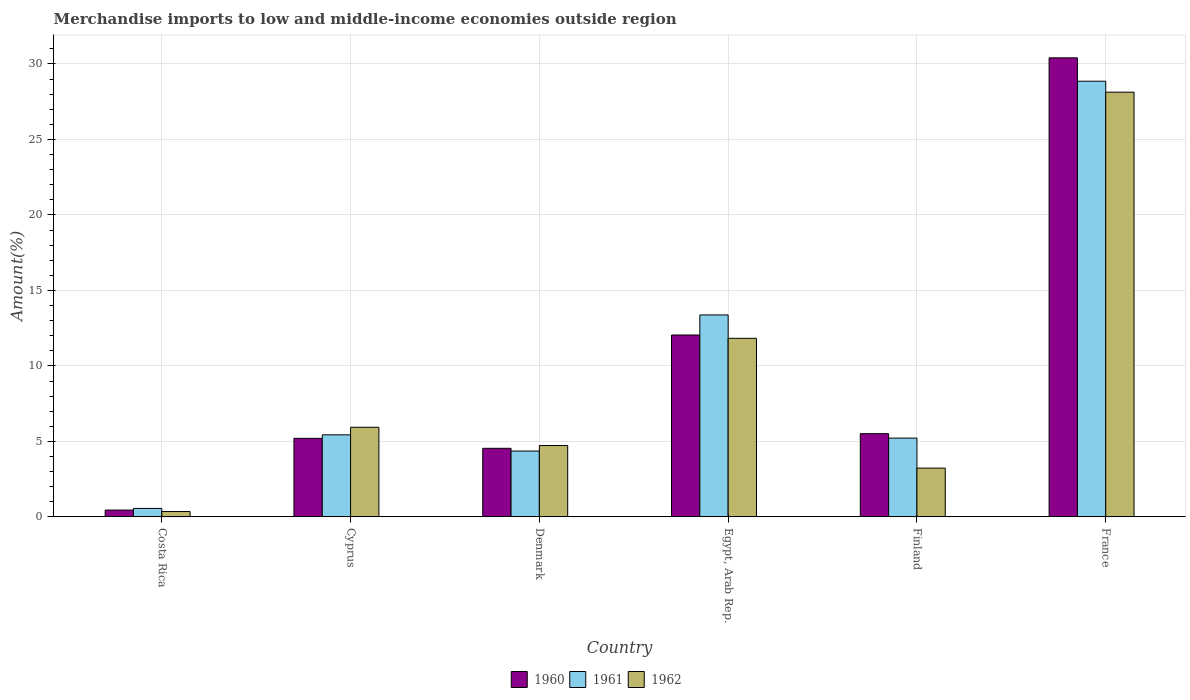Are the number of bars on each tick of the X-axis equal?
Offer a terse response. Yes. What is the percentage of amount earned from merchandise imports in 1960 in Finland?
Your answer should be very brief. 5.51. Across all countries, what is the maximum percentage of amount earned from merchandise imports in 1961?
Your answer should be very brief. 28.86. Across all countries, what is the minimum percentage of amount earned from merchandise imports in 1960?
Keep it short and to the point. 0.45. In which country was the percentage of amount earned from merchandise imports in 1961 maximum?
Keep it short and to the point. France. What is the total percentage of amount earned from merchandise imports in 1962 in the graph?
Your answer should be very brief. 54.22. What is the difference between the percentage of amount earned from merchandise imports in 1961 in Denmark and that in Finland?
Make the answer very short. -0.86. What is the difference between the percentage of amount earned from merchandise imports in 1962 in Cyprus and the percentage of amount earned from merchandise imports in 1960 in Finland?
Keep it short and to the point. 0.43. What is the average percentage of amount earned from merchandise imports in 1962 per country?
Ensure brevity in your answer.  9.04. What is the difference between the percentage of amount earned from merchandise imports of/in 1961 and percentage of amount earned from merchandise imports of/in 1960 in Finland?
Ensure brevity in your answer.  -0.29. In how many countries, is the percentage of amount earned from merchandise imports in 1961 greater than 22 %?
Your answer should be compact. 1. What is the ratio of the percentage of amount earned from merchandise imports in 1961 in Denmark to that in France?
Offer a very short reply. 0.15. Is the percentage of amount earned from merchandise imports in 1961 in Denmark less than that in France?
Provide a short and direct response. Yes. Is the difference between the percentage of amount earned from merchandise imports in 1961 in Costa Rica and Cyprus greater than the difference between the percentage of amount earned from merchandise imports in 1960 in Costa Rica and Cyprus?
Offer a terse response. No. What is the difference between the highest and the second highest percentage of amount earned from merchandise imports in 1962?
Keep it short and to the point. -16.3. What is the difference between the highest and the lowest percentage of amount earned from merchandise imports in 1961?
Ensure brevity in your answer.  28.29. In how many countries, is the percentage of amount earned from merchandise imports in 1960 greater than the average percentage of amount earned from merchandise imports in 1960 taken over all countries?
Ensure brevity in your answer.  2. Is it the case that in every country, the sum of the percentage of amount earned from merchandise imports in 1962 and percentage of amount earned from merchandise imports in 1961 is greater than the percentage of amount earned from merchandise imports in 1960?
Offer a terse response. Yes. How many bars are there?
Give a very brief answer. 18. How many countries are there in the graph?
Your response must be concise. 6. Does the graph contain grids?
Keep it short and to the point. Yes. How many legend labels are there?
Provide a succinct answer. 3. What is the title of the graph?
Your answer should be compact. Merchandise imports to low and middle-income economies outside region. Does "1960" appear as one of the legend labels in the graph?
Offer a very short reply. Yes. What is the label or title of the Y-axis?
Make the answer very short. Amount(%). What is the Amount(%) of 1960 in Costa Rica?
Offer a very short reply. 0.45. What is the Amount(%) in 1961 in Costa Rica?
Your answer should be compact. 0.56. What is the Amount(%) in 1962 in Costa Rica?
Give a very brief answer. 0.36. What is the Amount(%) in 1960 in Cyprus?
Provide a short and direct response. 5.21. What is the Amount(%) of 1961 in Cyprus?
Provide a short and direct response. 5.44. What is the Amount(%) of 1962 in Cyprus?
Provide a short and direct response. 5.94. What is the Amount(%) of 1960 in Denmark?
Keep it short and to the point. 4.54. What is the Amount(%) of 1961 in Denmark?
Make the answer very short. 4.36. What is the Amount(%) of 1962 in Denmark?
Provide a short and direct response. 4.73. What is the Amount(%) of 1960 in Egypt, Arab Rep.?
Make the answer very short. 12.05. What is the Amount(%) of 1961 in Egypt, Arab Rep.?
Ensure brevity in your answer.  13.38. What is the Amount(%) of 1962 in Egypt, Arab Rep.?
Provide a succinct answer. 11.83. What is the Amount(%) in 1960 in Finland?
Keep it short and to the point. 5.51. What is the Amount(%) of 1961 in Finland?
Ensure brevity in your answer.  5.22. What is the Amount(%) of 1962 in Finland?
Your answer should be compact. 3.23. What is the Amount(%) in 1960 in France?
Give a very brief answer. 30.4. What is the Amount(%) of 1961 in France?
Provide a short and direct response. 28.86. What is the Amount(%) of 1962 in France?
Provide a short and direct response. 28.13. Across all countries, what is the maximum Amount(%) of 1960?
Make the answer very short. 30.4. Across all countries, what is the maximum Amount(%) of 1961?
Offer a very short reply. 28.86. Across all countries, what is the maximum Amount(%) of 1962?
Provide a succinct answer. 28.13. Across all countries, what is the minimum Amount(%) in 1960?
Keep it short and to the point. 0.45. Across all countries, what is the minimum Amount(%) of 1961?
Provide a short and direct response. 0.56. Across all countries, what is the minimum Amount(%) of 1962?
Give a very brief answer. 0.36. What is the total Amount(%) of 1960 in the graph?
Keep it short and to the point. 58.17. What is the total Amount(%) of 1961 in the graph?
Keep it short and to the point. 57.82. What is the total Amount(%) of 1962 in the graph?
Offer a very short reply. 54.22. What is the difference between the Amount(%) in 1960 in Costa Rica and that in Cyprus?
Offer a terse response. -4.75. What is the difference between the Amount(%) in 1961 in Costa Rica and that in Cyprus?
Provide a succinct answer. -4.87. What is the difference between the Amount(%) in 1962 in Costa Rica and that in Cyprus?
Offer a terse response. -5.58. What is the difference between the Amount(%) in 1960 in Costa Rica and that in Denmark?
Provide a short and direct response. -4.09. What is the difference between the Amount(%) in 1961 in Costa Rica and that in Denmark?
Give a very brief answer. -3.8. What is the difference between the Amount(%) of 1962 in Costa Rica and that in Denmark?
Make the answer very short. -4.37. What is the difference between the Amount(%) of 1960 in Costa Rica and that in Egypt, Arab Rep.?
Give a very brief answer. -11.59. What is the difference between the Amount(%) in 1961 in Costa Rica and that in Egypt, Arab Rep.?
Offer a terse response. -12.81. What is the difference between the Amount(%) of 1962 in Costa Rica and that in Egypt, Arab Rep.?
Provide a short and direct response. -11.47. What is the difference between the Amount(%) of 1960 in Costa Rica and that in Finland?
Provide a succinct answer. -5.06. What is the difference between the Amount(%) in 1961 in Costa Rica and that in Finland?
Give a very brief answer. -4.66. What is the difference between the Amount(%) in 1962 in Costa Rica and that in Finland?
Provide a succinct answer. -2.88. What is the difference between the Amount(%) of 1960 in Costa Rica and that in France?
Offer a terse response. -29.95. What is the difference between the Amount(%) in 1961 in Costa Rica and that in France?
Your response must be concise. -28.29. What is the difference between the Amount(%) of 1962 in Costa Rica and that in France?
Your response must be concise. -27.77. What is the difference between the Amount(%) in 1960 in Cyprus and that in Denmark?
Provide a short and direct response. 0.66. What is the difference between the Amount(%) in 1961 in Cyprus and that in Denmark?
Give a very brief answer. 1.07. What is the difference between the Amount(%) of 1962 in Cyprus and that in Denmark?
Keep it short and to the point. 1.21. What is the difference between the Amount(%) in 1960 in Cyprus and that in Egypt, Arab Rep.?
Ensure brevity in your answer.  -6.84. What is the difference between the Amount(%) in 1961 in Cyprus and that in Egypt, Arab Rep.?
Your answer should be compact. -7.94. What is the difference between the Amount(%) of 1962 in Cyprus and that in Egypt, Arab Rep.?
Ensure brevity in your answer.  -5.89. What is the difference between the Amount(%) of 1960 in Cyprus and that in Finland?
Provide a succinct answer. -0.31. What is the difference between the Amount(%) of 1961 in Cyprus and that in Finland?
Your response must be concise. 0.22. What is the difference between the Amount(%) of 1962 in Cyprus and that in Finland?
Ensure brevity in your answer.  2.71. What is the difference between the Amount(%) of 1960 in Cyprus and that in France?
Give a very brief answer. -25.2. What is the difference between the Amount(%) of 1961 in Cyprus and that in France?
Offer a very short reply. -23.42. What is the difference between the Amount(%) in 1962 in Cyprus and that in France?
Your response must be concise. -22.19. What is the difference between the Amount(%) in 1960 in Denmark and that in Egypt, Arab Rep.?
Provide a short and direct response. -7.5. What is the difference between the Amount(%) in 1961 in Denmark and that in Egypt, Arab Rep.?
Offer a terse response. -9.01. What is the difference between the Amount(%) of 1962 in Denmark and that in Egypt, Arab Rep.?
Provide a succinct answer. -7.1. What is the difference between the Amount(%) of 1960 in Denmark and that in Finland?
Make the answer very short. -0.97. What is the difference between the Amount(%) of 1961 in Denmark and that in Finland?
Provide a succinct answer. -0.86. What is the difference between the Amount(%) in 1962 in Denmark and that in Finland?
Offer a very short reply. 1.49. What is the difference between the Amount(%) of 1960 in Denmark and that in France?
Offer a terse response. -25.86. What is the difference between the Amount(%) in 1961 in Denmark and that in France?
Make the answer very short. -24.49. What is the difference between the Amount(%) in 1962 in Denmark and that in France?
Give a very brief answer. -23.4. What is the difference between the Amount(%) in 1960 in Egypt, Arab Rep. and that in Finland?
Give a very brief answer. 6.54. What is the difference between the Amount(%) in 1961 in Egypt, Arab Rep. and that in Finland?
Keep it short and to the point. 8.16. What is the difference between the Amount(%) of 1962 in Egypt, Arab Rep. and that in Finland?
Your answer should be compact. 8.6. What is the difference between the Amount(%) of 1960 in Egypt, Arab Rep. and that in France?
Provide a succinct answer. -18.36. What is the difference between the Amount(%) in 1961 in Egypt, Arab Rep. and that in France?
Ensure brevity in your answer.  -15.48. What is the difference between the Amount(%) of 1962 in Egypt, Arab Rep. and that in France?
Offer a terse response. -16.3. What is the difference between the Amount(%) in 1960 in Finland and that in France?
Give a very brief answer. -24.89. What is the difference between the Amount(%) in 1961 in Finland and that in France?
Provide a succinct answer. -23.64. What is the difference between the Amount(%) in 1962 in Finland and that in France?
Offer a very short reply. -24.9. What is the difference between the Amount(%) of 1960 in Costa Rica and the Amount(%) of 1961 in Cyprus?
Your answer should be compact. -4.98. What is the difference between the Amount(%) in 1960 in Costa Rica and the Amount(%) in 1962 in Cyprus?
Keep it short and to the point. -5.48. What is the difference between the Amount(%) in 1961 in Costa Rica and the Amount(%) in 1962 in Cyprus?
Give a very brief answer. -5.38. What is the difference between the Amount(%) in 1960 in Costa Rica and the Amount(%) in 1961 in Denmark?
Your answer should be compact. -3.91. What is the difference between the Amount(%) in 1960 in Costa Rica and the Amount(%) in 1962 in Denmark?
Keep it short and to the point. -4.27. What is the difference between the Amount(%) of 1961 in Costa Rica and the Amount(%) of 1962 in Denmark?
Keep it short and to the point. -4.16. What is the difference between the Amount(%) in 1960 in Costa Rica and the Amount(%) in 1961 in Egypt, Arab Rep.?
Offer a very short reply. -12.92. What is the difference between the Amount(%) of 1960 in Costa Rica and the Amount(%) of 1962 in Egypt, Arab Rep.?
Provide a short and direct response. -11.37. What is the difference between the Amount(%) of 1961 in Costa Rica and the Amount(%) of 1962 in Egypt, Arab Rep.?
Offer a terse response. -11.27. What is the difference between the Amount(%) of 1960 in Costa Rica and the Amount(%) of 1961 in Finland?
Your response must be concise. -4.76. What is the difference between the Amount(%) in 1960 in Costa Rica and the Amount(%) in 1962 in Finland?
Offer a very short reply. -2.78. What is the difference between the Amount(%) in 1961 in Costa Rica and the Amount(%) in 1962 in Finland?
Give a very brief answer. -2.67. What is the difference between the Amount(%) in 1960 in Costa Rica and the Amount(%) in 1961 in France?
Ensure brevity in your answer.  -28.4. What is the difference between the Amount(%) in 1960 in Costa Rica and the Amount(%) in 1962 in France?
Offer a very short reply. -27.67. What is the difference between the Amount(%) of 1961 in Costa Rica and the Amount(%) of 1962 in France?
Provide a short and direct response. -27.57. What is the difference between the Amount(%) in 1960 in Cyprus and the Amount(%) in 1961 in Denmark?
Ensure brevity in your answer.  0.84. What is the difference between the Amount(%) in 1960 in Cyprus and the Amount(%) in 1962 in Denmark?
Offer a very short reply. 0.48. What is the difference between the Amount(%) of 1961 in Cyprus and the Amount(%) of 1962 in Denmark?
Offer a very short reply. 0.71. What is the difference between the Amount(%) of 1960 in Cyprus and the Amount(%) of 1961 in Egypt, Arab Rep.?
Offer a very short reply. -8.17. What is the difference between the Amount(%) of 1960 in Cyprus and the Amount(%) of 1962 in Egypt, Arab Rep.?
Your response must be concise. -6.62. What is the difference between the Amount(%) of 1961 in Cyprus and the Amount(%) of 1962 in Egypt, Arab Rep.?
Ensure brevity in your answer.  -6.39. What is the difference between the Amount(%) of 1960 in Cyprus and the Amount(%) of 1961 in Finland?
Provide a succinct answer. -0.01. What is the difference between the Amount(%) of 1960 in Cyprus and the Amount(%) of 1962 in Finland?
Offer a terse response. 1.97. What is the difference between the Amount(%) of 1961 in Cyprus and the Amount(%) of 1962 in Finland?
Provide a short and direct response. 2.2. What is the difference between the Amount(%) of 1960 in Cyprus and the Amount(%) of 1961 in France?
Keep it short and to the point. -23.65. What is the difference between the Amount(%) in 1960 in Cyprus and the Amount(%) in 1962 in France?
Ensure brevity in your answer.  -22.92. What is the difference between the Amount(%) in 1961 in Cyprus and the Amount(%) in 1962 in France?
Keep it short and to the point. -22.69. What is the difference between the Amount(%) of 1960 in Denmark and the Amount(%) of 1961 in Egypt, Arab Rep.?
Offer a very short reply. -8.83. What is the difference between the Amount(%) of 1960 in Denmark and the Amount(%) of 1962 in Egypt, Arab Rep.?
Your answer should be very brief. -7.28. What is the difference between the Amount(%) of 1961 in Denmark and the Amount(%) of 1962 in Egypt, Arab Rep.?
Provide a short and direct response. -7.47. What is the difference between the Amount(%) of 1960 in Denmark and the Amount(%) of 1961 in Finland?
Provide a succinct answer. -0.67. What is the difference between the Amount(%) in 1960 in Denmark and the Amount(%) in 1962 in Finland?
Your answer should be very brief. 1.31. What is the difference between the Amount(%) of 1961 in Denmark and the Amount(%) of 1962 in Finland?
Your answer should be very brief. 1.13. What is the difference between the Amount(%) in 1960 in Denmark and the Amount(%) in 1961 in France?
Provide a succinct answer. -24.31. What is the difference between the Amount(%) of 1960 in Denmark and the Amount(%) of 1962 in France?
Offer a terse response. -23.58. What is the difference between the Amount(%) in 1961 in Denmark and the Amount(%) in 1962 in France?
Provide a succinct answer. -23.77. What is the difference between the Amount(%) of 1960 in Egypt, Arab Rep. and the Amount(%) of 1961 in Finland?
Provide a short and direct response. 6.83. What is the difference between the Amount(%) of 1960 in Egypt, Arab Rep. and the Amount(%) of 1962 in Finland?
Your response must be concise. 8.81. What is the difference between the Amount(%) of 1961 in Egypt, Arab Rep. and the Amount(%) of 1962 in Finland?
Your answer should be very brief. 10.14. What is the difference between the Amount(%) in 1960 in Egypt, Arab Rep. and the Amount(%) in 1961 in France?
Offer a very short reply. -16.81. What is the difference between the Amount(%) in 1960 in Egypt, Arab Rep. and the Amount(%) in 1962 in France?
Offer a very short reply. -16.08. What is the difference between the Amount(%) in 1961 in Egypt, Arab Rep. and the Amount(%) in 1962 in France?
Your answer should be very brief. -14.75. What is the difference between the Amount(%) in 1960 in Finland and the Amount(%) in 1961 in France?
Your response must be concise. -23.34. What is the difference between the Amount(%) of 1960 in Finland and the Amount(%) of 1962 in France?
Your answer should be very brief. -22.62. What is the difference between the Amount(%) in 1961 in Finland and the Amount(%) in 1962 in France?
Offer a very short reply. -22.91. What is the average Amount(%) in 1960 per country?
Your answer should be compact. 9.7. What is the average Amount(%) of 1961 per country?
Your answer should be very brief. 9.64. What is the average Amount(%) of 1962 per country?
Make the answer very short. 9.04. What is the difference between the Amount(%) of 1960 and Amount(%) of 1961 in Costa Rica?
Keep it short and to the point. -0.11. What is the difference between the Amount(%) of 1960 and Amount(%) of 1962 in Costa Rica?
Ensure brevity in your answer.  0.1. What is the difference between the Amount(%) of 1961 and Amount(%) of 1962 in Costa Rica?
Provide a short and direct response. 0.21. What is the difference between the Amount(%) in 1960 and Amount(%) in 1961 in Cyprus?
Your answer should be compact. -0.23. What is the difference between the Amount(%) in 1960 and Amount(%) in 1962 in Cyprus?
Your answer should be compact. -0.73. What is the difference between the Amount(%) in 1961 and Amount(%) in 1962 in Cyprus?
Keep it short and to the point. -0.5. What is the difference between the Amount(%) of 1960 and Amount(%) of 1961 in Denmark?
Ensure brevity in your answer.  0.18. What is the difference between the Amount(%) in 1960 and Amount(%) in 1962 in Denmark?
Give a very brief answer. -0.18. What is the difference between the Amount(%) of 1961 and Amount(%) of 1962 in Denmark?
Offer a terse response. -0.36. What is the difference between the Amount(%) of 1960 and Amount(%) of 1961 in Egypt, Arab Rep.?
Your response must be concise. -1.33. What is the difference between the Amount(%) of 1960 and Amount(%) of 1962 in Egypt, Arab Rep.?
Offer a very short reply. 0.22. What is the difference between the Amount(%) in 1961 and Amount(%) in 1962 in Egypt, Arab Rep.?
Give a very brief answer. 1.55. What is the difference between the Amount(%) of 1960 and Amount(%) of 1961 in Finland?
Your response must be concise. 0.29. What is the difference between the Amount(%) of 1960 and Amount(%) of 1962 in Finland?
Your response must be concise. 2.28. What is the difference between the Amount(%) in 1961 and Amount(%) in 1962 in Finland?
Make the answer very short. 1.99. What is the difference between the Amount(%) of 1960 and Amount(%) of 1961 in France?
Your answer should be compact. 1.55. What is the difference between the Amount(%) of 1960 and Amount(%) of 1962 in France?
Make the answer very short. 2.28. What is the difference between the Amount(%) of 1961 and Amount(%) of 1962 in France?
Your answer should be compact. 0.73. What is the ratio of the Amount(%) of 1960 in Costa Rica to that in Cyprus?
Provide a short and direct response. 0.09. What is the ratio of the Amount(%) in 1961 in Costa Rica to that in Cyprus?
Your answer should be compact. 0.1. What is the ratio of the Amount(%) of 1962 in Costa Rica to that in Cyprus?
Provide a short and direct response. 0.06. What is the ratio of the Amount(%) of 1960 in Costa Rica to that in Denmark?
Provide a succinct answer. 0.1. What is the ratio of the Amount(%) in 1961 in Costa Rica to that in Denmark?
Your response must be concise. 0.13. What is the ratio of the Amount(%) in 1962 in Costa Rica to that in Denmark?
Offer a terse response. 0.08. What is the ratio of the Amount(%) in 1960 in Costa Rica to that in Egypt, Arab Rep.?
Provide a succinct answer. 0.04. What is the ratio of the Amount(%) of 1961 in Costa Rica to that in Egypt, Arab Rep.?
Offer a very short reply. 0.04. What is the ratio of the Amount(%) of 1962 in Costa Rica to that in Egypt, Arab Rep.?
Keep it short and to the point. 0.03. What is the ratio of the Amount(%) in 1960 in Costa Rica to that in Finland?
Ensure brevity in your answer.  0.08. What is the ratio of the Amount(%) in 1961 in Costa Rica to that in Finland?
Make the answer very short. 0.11. What is the ratio of the Amount(%) in 1962 in Costa Rica to that in Finland?
Make the answer very short. 0.11. What is the ratio of the Amount(%) of 1960 in Costa Rica to that in France?
Make the answer very short. 0.01. What is the ratio of the Amount(%) of 1961 in Costa Rica to that in France?
Your answer should be very brief. 0.02. What is the ratio of the Amount(%) of 1962 in Costa Rica to that in France?
Your answer should be compact. 0.01. What is the ratio of the Amount(%) of 1960 in Cyprus to that in Denmark?
Your response must be concise. 1.15. What is the ratio of the Amount(%) of 1961 in Cyprus to that in Denmark?
Offer a very short reply. 1.25. What is the ratio of the Amount(%) in 1962 in Cyprus to that in Denmark?
Your answer should be compact. 1.26. What is the ratio of the Amount(%) of 1960 in Cyprus to that in Egypt, Arab Rep.?
Offer a terse response. 0.43. What is the ratio of the Amount(%) in 1961 in Cyprus to that in Egypt, Arab Rep.?
Give a very brief answer. 0.41. What is the ratio of the Amount(%) of 1962 in Cyprus to that in Egypt, Arab Rep.?
Ensure brevity in your answer.  0.5. What is the ratio of the Amount(%) in 1960 in Cyprus to that in Finland?
Offer a terse response. 0.94. What is the ratio of the Amount(%) of 1961 in Cyprus to that in Finland?
Your answer should be very brief. 1.04. What is the ratio of the Amount(%) in 1962 in Cyprus to that in Finland?
Offer a terse response. 1.84. What is the ratio of the Amount(%) in 1960 in Cyprus to that in France?
Give a very brief answer. 0.17. What is the ratio of the Amount(%) in 1961 in Cyprus to that in France?
Keep it short and to the point. 0.19. What is the ratio of the Amount(%) in 1962 in Cyprus to that in France?
Provide a short and direct response. 0.21. What is the ratio of the Amount(%) of 1960 in Denmark to that in Egypt, Arab Rep.?
Make the answer very short. 0.38. What is the ratio of the Amount(%) of 1961 in Denmark to that in Egypt, Arab Rep.?
Make the answer very short. 0.33. What is the ratio of the Amount(%) in 1962 in Denmark to that in Egypt, Arab Rep.?
Offer a very short reply. 0.4. What is the ratio of the Amount(%) of 1960 in Denmark to that in Finland?
Give a very brief answer. 0.82. What is the ratio of the Amount(%) of 1961 in Denmark to that in Finland?
Your answer should be very brief. 0.84. What is the ratio of the Amount(%) of 1962 in Denmark to that in Finland?
Provide a short and direct response. 1.46. What is the ratio of the Amount(%) in 1960 in Denmark to that in France?
Offer a terse response. 0.15. What is the ratio of the Amount(%) of 1961 in Denmark to that in France?
Ensure brevity in your answer.  0.15. What is the ratio of the Amount(%) of 1962 in Denmark to that in France?
Make the answer very short. 0.17. What is the ratio of the Amount(%) in 1960 in Egypt, Arab Rep. to that in Finland?
Your answer should be very brief. 2.19. What is the ratio of the Amount(%) of 1961 in Egypt, Arab Rep. to that in Finland?
Ensure brevity in your answer.  2.56. What is the ratio of the Amount(%) of 1962 in Egypt, Arab Rep. to that in Finland?
Provide a succinct answer. 3.66. What is the ratio of the Amount(%) of 1960 in Egypt, Arab Rep. to that in France?
Your answer should be very brief. 0.4. What is the ratio of the Amount(%) in 1961 in Egypt, Arab Rep. to that in France?
Your answer should be very brief. 0.46. What is the ratio of the Amount(%) of 1962 in Egypt, Arab Rep. to that in France?
Your response must be concise. 0.42. What is the ratio of the Amount(%) of 1960 in Finland to that in France?
Ensure brevity in your answer.  0.18. What is the ratio of the Amount(%) of 1961 in Finland to that in France?
Provide a succinct answer. 0.18. What is the ratio of the Amount(%) in 1962 in Finland to that in France?
Your answer should be compact. 0.11. What is the difference between the highest and the second highest Amount(%) in 1960?
Your answer should be compact. 18.36. What is the difference between the highest and the second highest Amount(%) of 1961?
Give a very brief answer. 15.48. What is the difference between the highest and the second highest Amount(%) of 1962?
Your answer should be very brief. 16.3. What is the difference between the highest and the lowest Amount(%) of 1960?
Give a very brief answer. 29.95. What is the difference between the highest and the lowest Amount(%) in 1961?
Keep it short and to the point. 28.29. What is the difference between the highest and the lowest Amount(%) in 1962?
Offer a terse response. 27.77. 